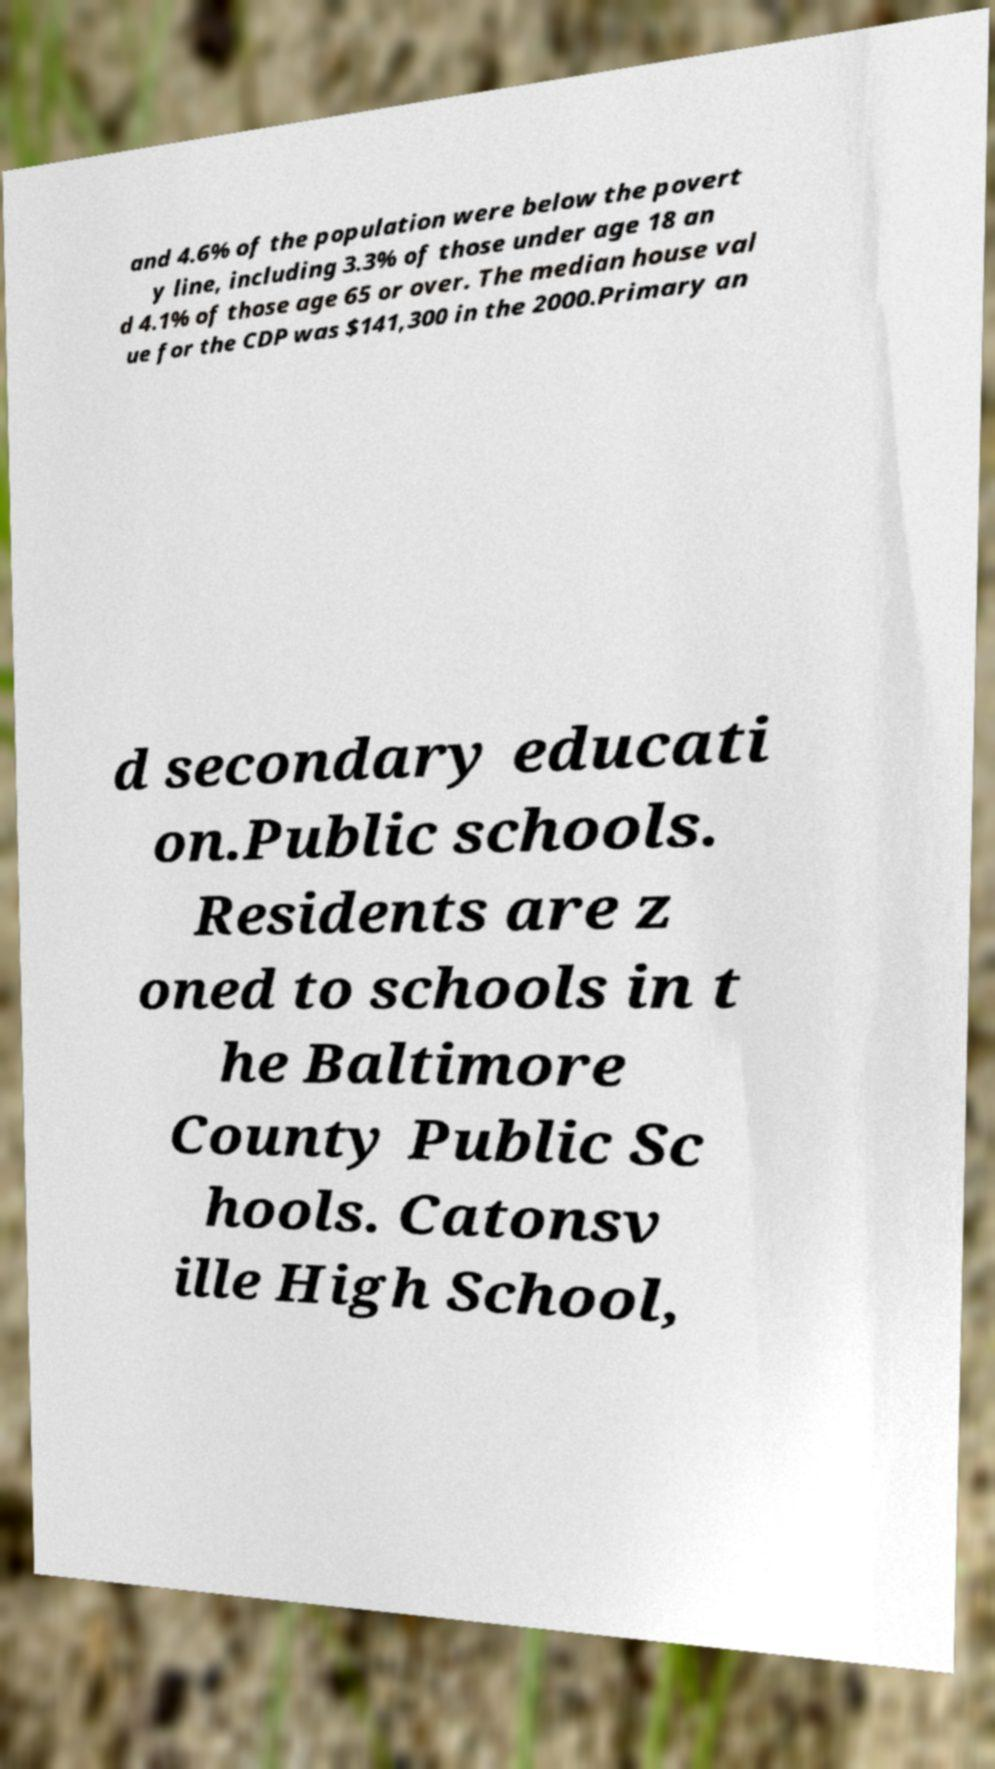Please read and relay the text visible in this image. What does it say? and 4.6% of the population were below the povert y line, including 3.3% of those under age 18 an d 4.1% of those age 65 or over. The median house val ue for the CDP was $141,300 in the 2000.Primary an d secondary educati on.Public schools. Residents are z oned to schools in t he Baltimore County Public Sc hools. Catonsv ille High School, 